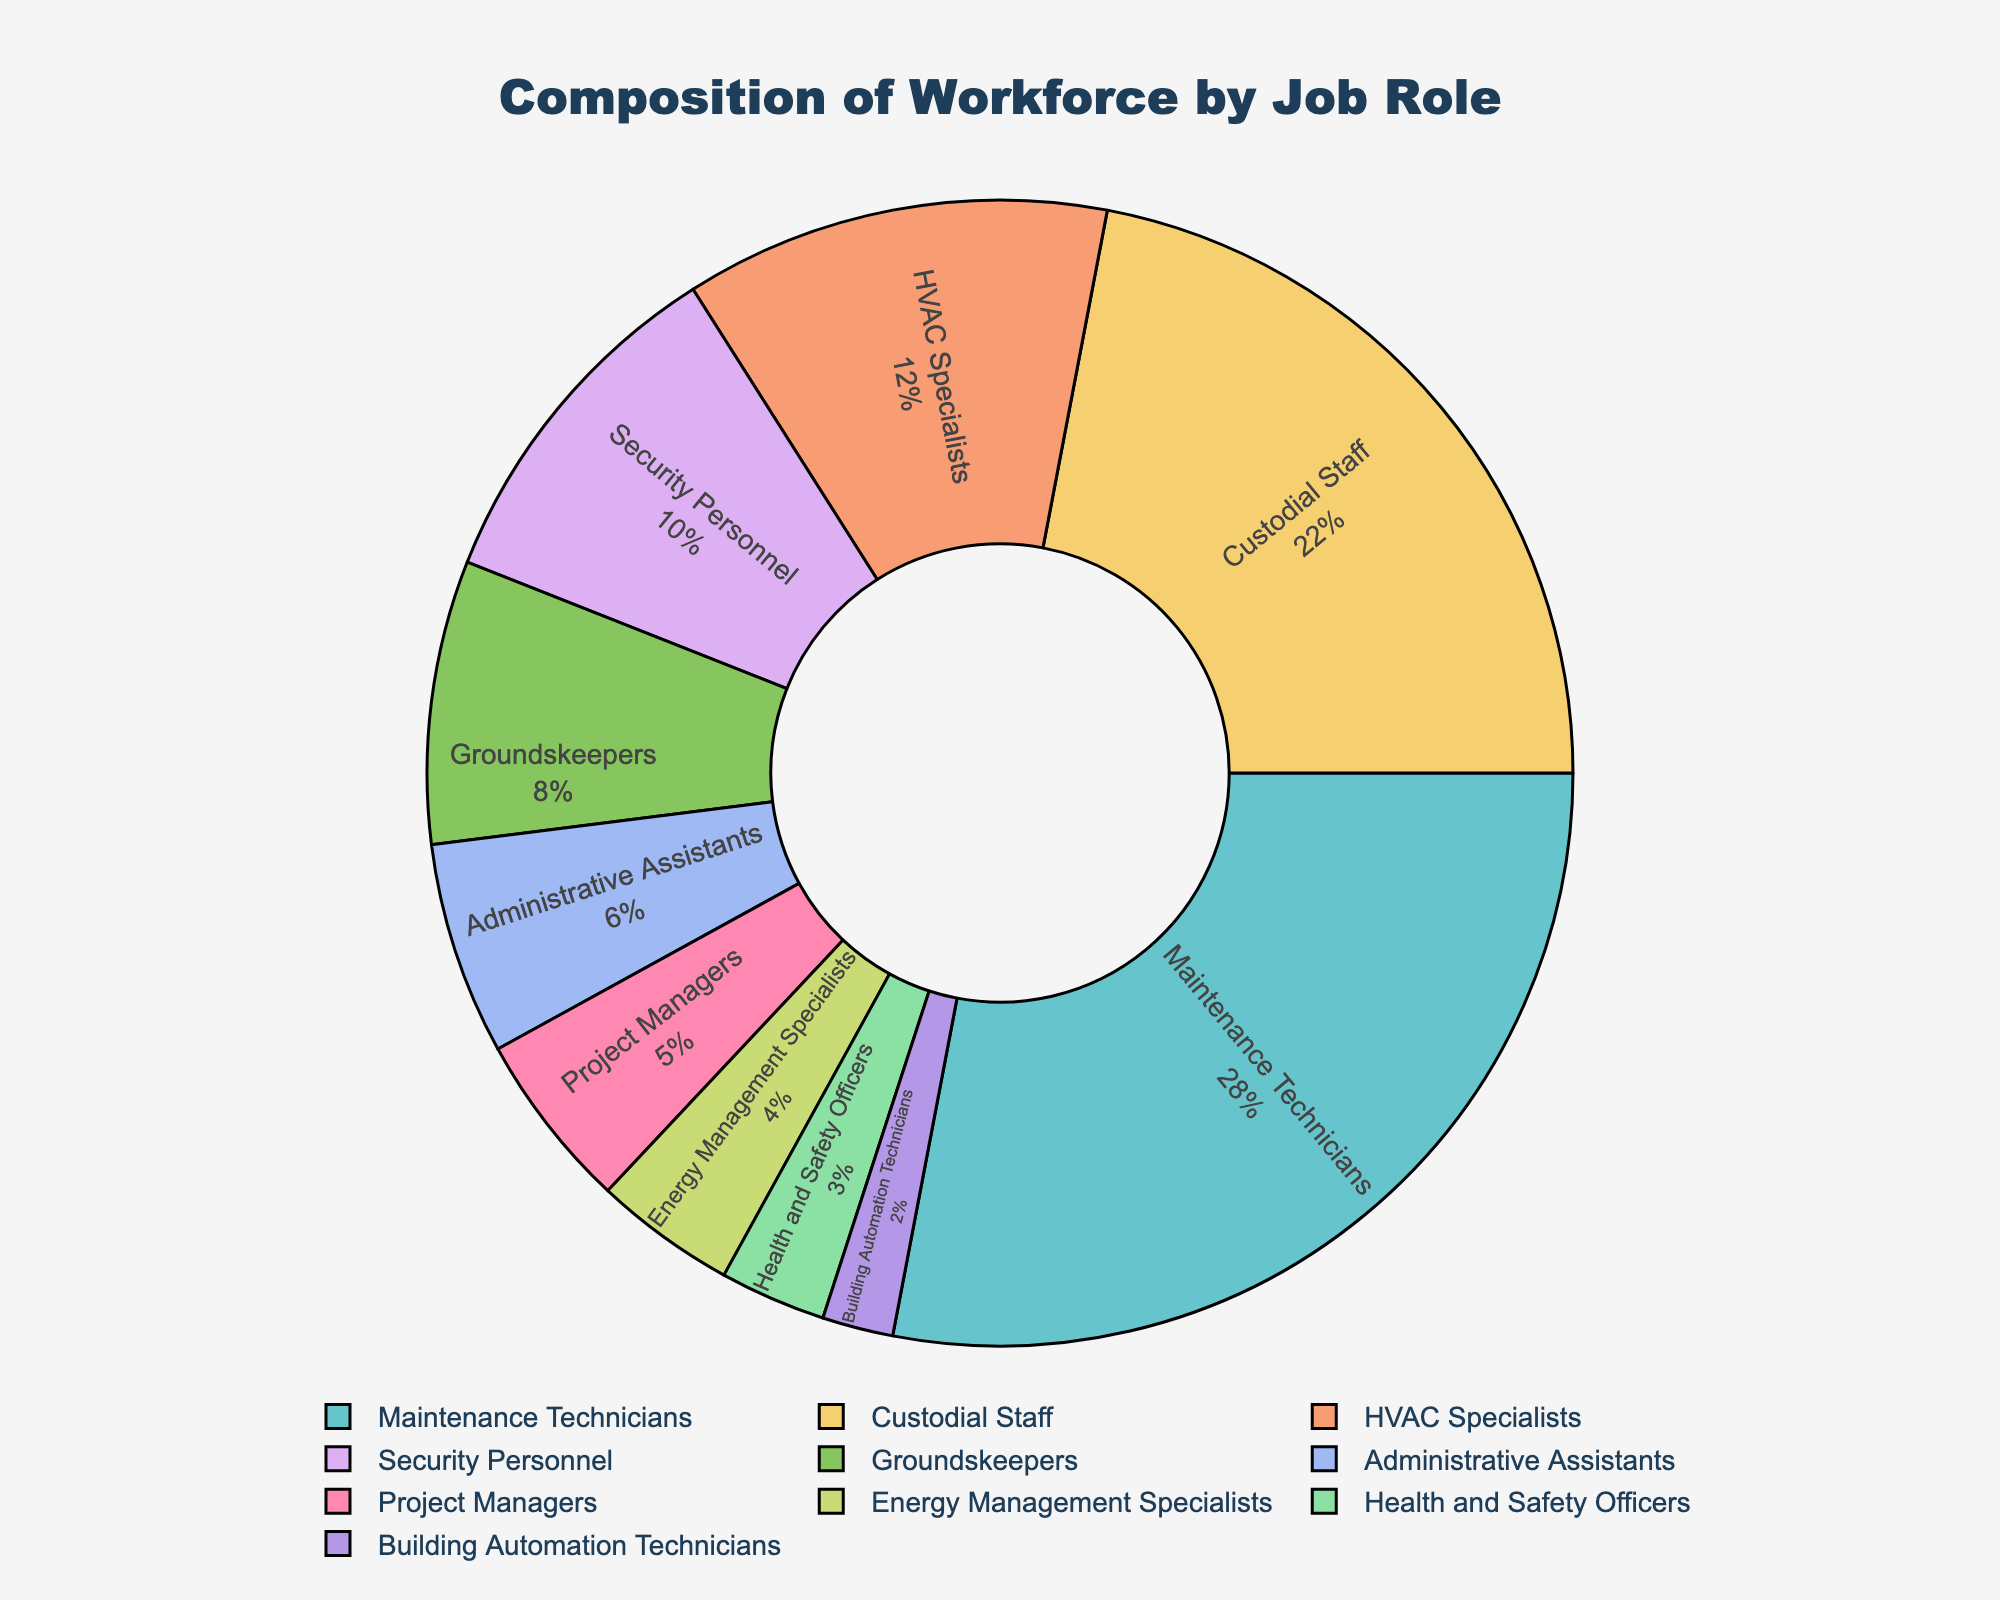Which job role has the highest percentage of the workforce? The figure shows a pie chart with segments labeled with job roles and their corresponding percentages. The largest segment represents the job role with the highest percentage. The "Maintenance Technicians" segment is the largest with 28%.
Answer: Maintenance Technicians What is the combined percentage of Custodial Staff and HVAC Specialists? To find the combined percentage, add the percentages of Custodial Staff (22%) and HVAC Specialists (12%). The sum is 22% + 12% = 34%.
Answer: 34% Which job role counts for 6% of the workforce? By examining the figure, we notice the segment representing "Administrative Assistants" has a label indicating 6% of the workforce.
Answer: Administrative Assistants How does the percentage of Security Personnel compare to that of Groundskeepers? Comparing the segments, Security Personnel account for 10%, while Groundskeepers account for 8%. Therefore, Security Personnel have a higher percentage than Groundskeepers.
Answer: Security Personnel have a higher percentage What's the combined percentage of Health and Safety Officers, Building Automation Technicians, and Energy Management Specialists? Add the percentages: Health and Safety Officers (3%), Building Automation Technicians (2%), and Energy Management Specialists (4%). The total is 3% + 2% + 4% = 9%.
Answer: 9% Which job roles each occupy less than 10% of the workforce? The segments labeled with percentages below 10% are: HVAC Specialists (12%), Security Personnel (10%), Groundskeepers (8%), Administrative Assistants (6%), Project Managers (5%), Energy Management Specialists (4%), Health and Safety Officers (3%), and Building Automation Technicians (2%).
Answer: Groundskeepers, Administrative Assistants, Project Managers, Energy Management Specialists, Health and Safety Officers, Building Automation Technicians How many job roles collectively make up exactly 50% of the workforce? To find the job roles forming 50% collectively, we sum up the percentages in descending order until reaching 50%. Maintenance Technicians (28%) + Custodial Staff (22%) = 50%. Thus, it takes two job roles.
Answer: 2 How does the percentage of Maintenance Technicians compare to that of Project Managers and Health and Safety Officers combined? The percentage of Maintenance Technicians is 28%. The combined percentage of Project Managers (5%) and Health and Safety Officers (3%) is 5% + 3% = 8%. Therefore, Maintenance Technicians have a higher percentage (28%) compared to the combined 8%.
Answer: Maintenance Technicians have a higher percentage What is the difference in percentage between the highest and lowest job roles? The largest percentage is for Maintenance Technicians at 28%, and the smallest is for Building Automation Technicians at 2%. The difference is 28% - 2% = 26%.
Answer: 26% Which job role occupies a segment next to Health and Safety Officers? Examining the pie chart visually, Building Automation Technicians (2%) and Energy Management Specialists (4%) lie adjacent to the Health and Safety Officers (3%) segment.
Answer: Building Automation Technicians and Energy Management Specialists 